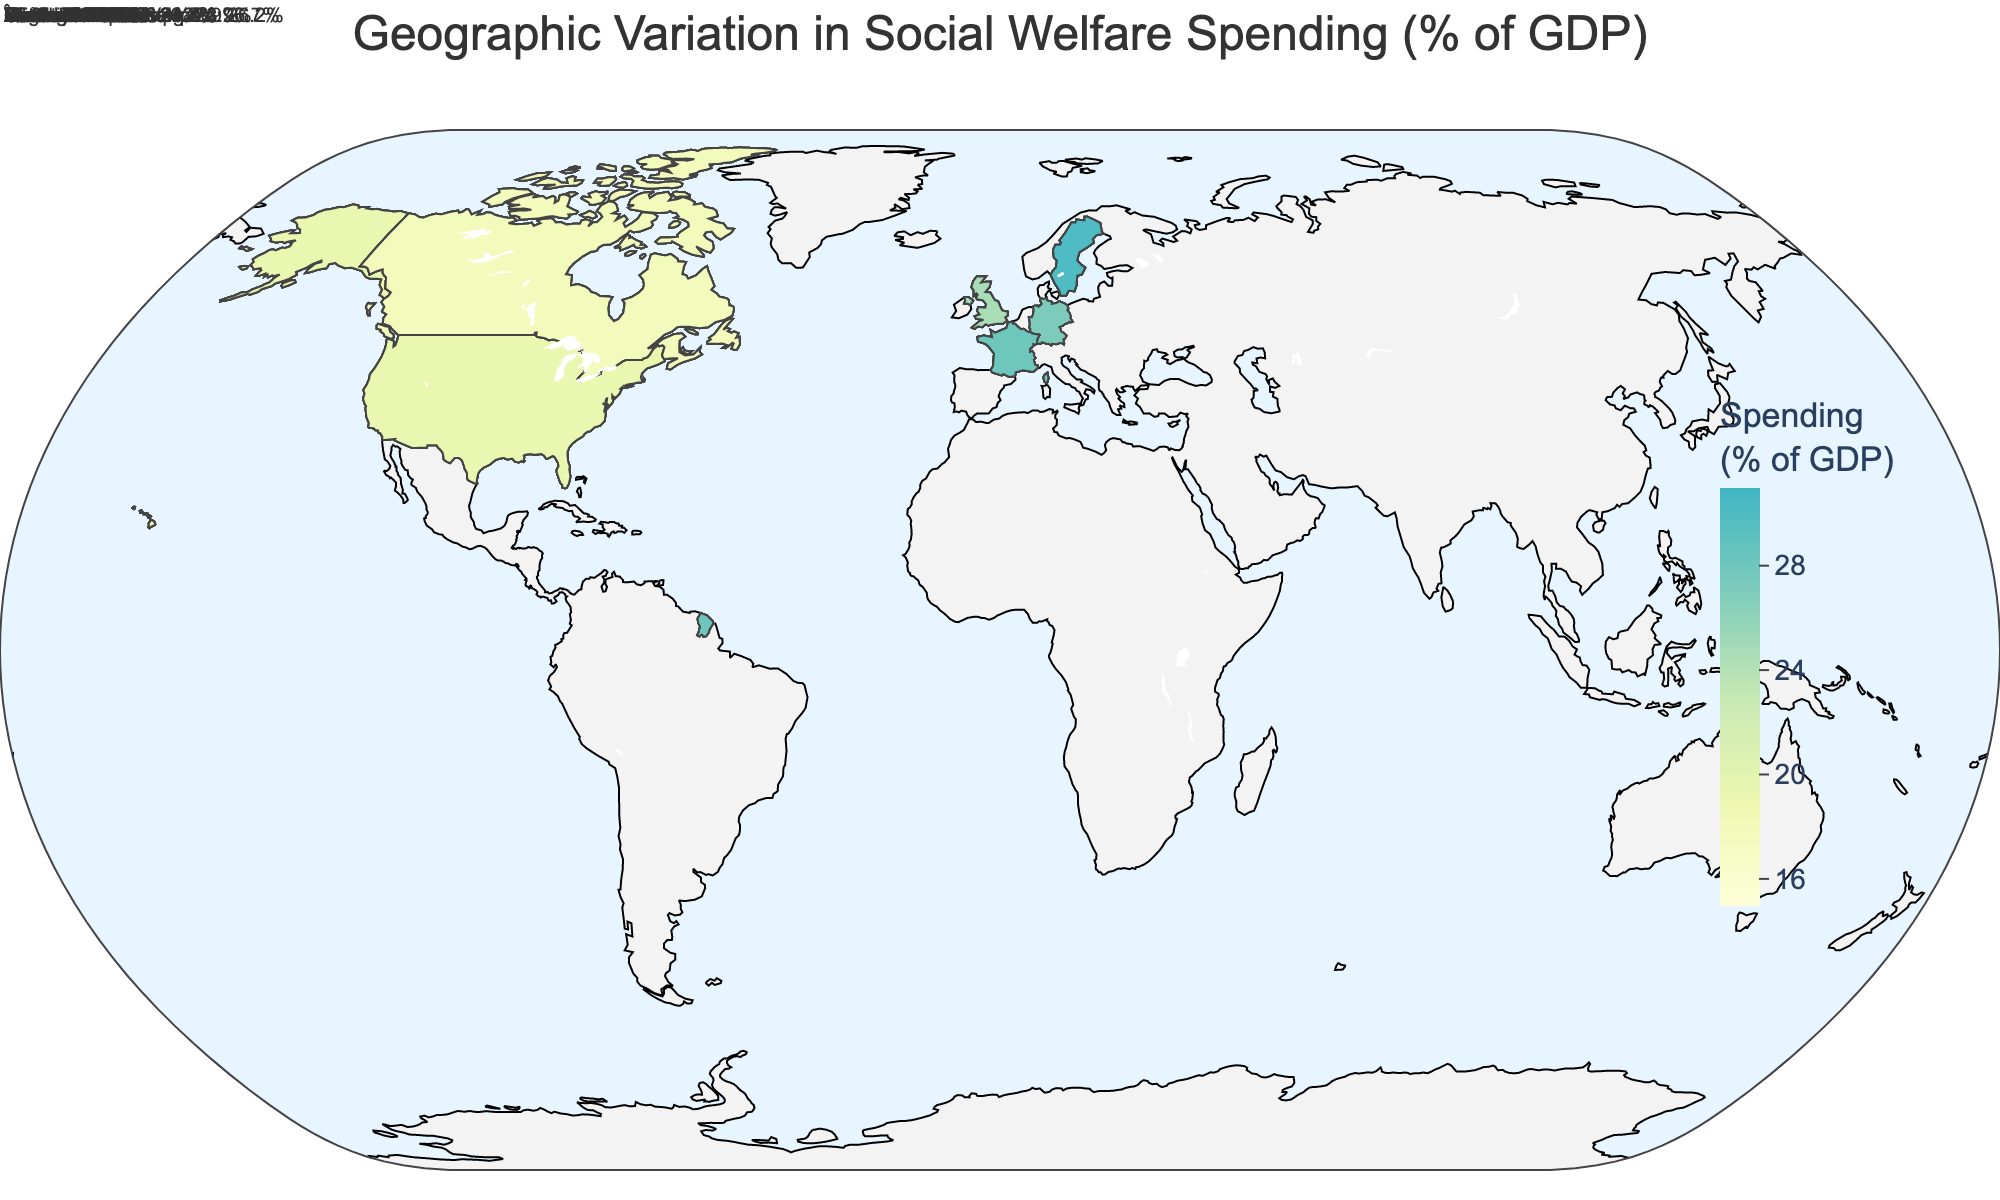What's the title of the figure? The title of the figure is usually displayed prominently at the top. Checking there, the title is "Geographic Variation in Social Welfare Spending (% of GDP)"
Answer: Geographic Variation in Social Welfare Spending (% of GDP) Which country has the highest social welfare spending as a percentage of GDP? The figure's color scale indicates that darker regions represent higher spending percentages. By examining the darkest regions, France, specifically Île-de-France, has the highest social welfare spending with 28.4% of GDP
Answer: France What is the range of social welfare spending percentages depicted in the figure? The color legend on the right side of the figure displays the range of values. The lower end of the range is 15% and the upper end is 31% as indicated by the color axis
Answer: 15% to 31% Which region in Sweden has the highest social welfare spending percentage? By focusing on Sweden within the figure and examining the annotations, Norrland has the highest social welfare spending percentage of 30.1%
Answer: Norrland What is the average social welfare spending percentage of the United States regions? The social welfare spending percentages for the United States regions are 20.5%, 18.7%, 16.2%, and 19.3%. Adding these values and dividing by the 4 regions: (20.5 + 18.7 + 16.2 + 19.3) / 4 = 18.675%
Answer: 18.675% Compare the social welfare spending percentages between England and Scotland in the United Kingdom. England has a social welfare spending percentage of 23.6% and Scotland has 25.1%. Scotland's percentage is 1.5% higher than England's
Answer: Scotland is 1.5% higher Which country in the figure shows a consistent high level of social welfare spending across its regions? By examining the color shading and annotations, Sweden displays consistently high social welfare spending percentages across its regions, all above 27%
Answer: Sweden What is the median social welfare spending percentage among Canadian regions? The social welfare spending percentages for Canadian regions are 22.1%, 25.8%, 21.4%, and 17.9%. Arranging these values in ascending order: 17.9%, 21.4%, 22.1%, 25.8%, the median is the average of the two middle numbers: (21.4 + 22.1) / 2 = 21.75%
Answer: 21.75% What region in Germany has the lowest social welfare spending percentage? By examining the annotations for Germany, Baden-Württemberg has the lowest social welfare spending percentage of 23.9%
Answer: Baden-Württemberg 